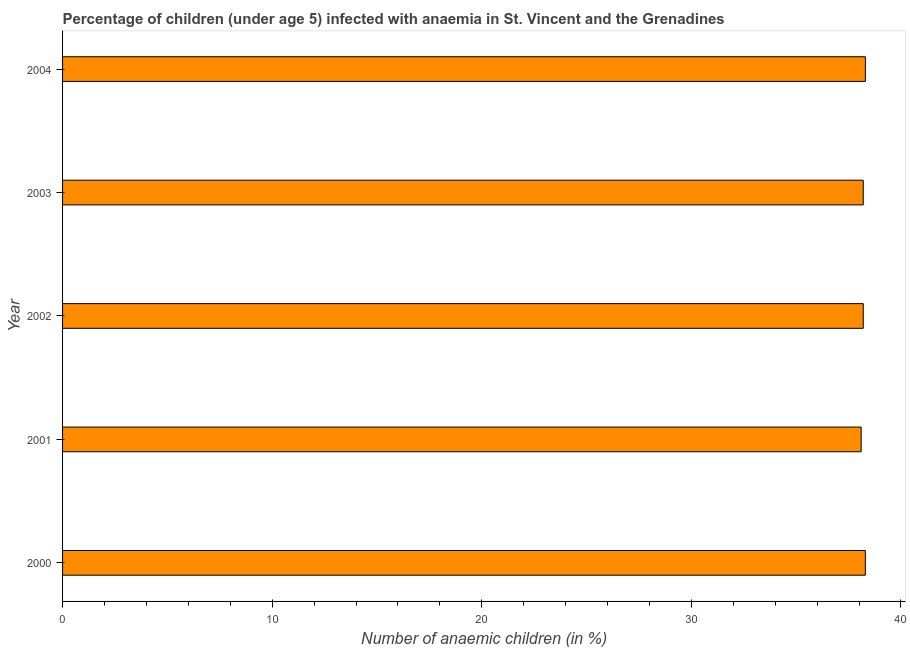Does the graph contain any zero values?
Make the answer very short. No. Does the graph contain grids?
Make the answer very short. No. What is the title of the graph?
Make the answer very short. Percentage of children (under age 5) infected with anaemia in St. Vincent and the Grenadines. What is the label or title of the X-axis?
Make the answer very short. Number of anaemic children (in %). What is the number of anaemic children in 2001?
Provide a succinct answer. 38.1. Across all years, what is the maximum number of anaemic children?
Make the answer very short. 38.3. Across all years, what is the minimum number of anaemic children?
Your answer should be compact. 38.1. In which year was the number of anaemic children maximum?
Offer a very short reply. 2000. In which year was the number of anaemic children minimum?
Offer a very short reply. 2001. What is the sum of the number of anaemic children?
Offer a terse response. 191.1. What is the average number of anaemic children per year?
Keep it short and to the point. 38.22. What is the median number of anaemic children?
Make the answer very short. 38.2. Do a majority of the years between 2003 and 2000 (inclusive) have number of anaemic children greater than 8 %?
Make the answer very short. Yes. What is the ratio of the number of anaemic children in 2001 to that in 2003?
Make the answer very short. 1. Is the number of anaemic children in 2000 less than that in 2004?
Provide a succinct answer. No. What is the difference between the highest and the lowest number of anaemic children?
Offer a terse response. 0.2. How many bars are there?
Offer a very short reply. 5. Are all the bars in the graph horizontal?
Ensure brevity in your answer.  Yes. How many years are there in the graph?
Offer a very short reply. 5. What is the difference between two consecutive major ticks on the X-axis?
Give a very brief answer. 10. Are the values on the major ticks of X-axis written in scientific E-notation?
Your response must be concise. No. What is the Number of anaemic children (in %) of 2000?
Provide a succinct answer. 38.3. What is the Number of anaemic children (in %) of 2001?
Make the answer very short. 38.1. What is the Number of anaemic children (in %) in 2002?
Offer a very short reply. 38.2. What is the Number of anaemic children (in %) in 2003?
Your response must be concise. 38.2. What is the Number of anaemic children (in %) in 2004?
Your answer should be very brief. 38.3. What is the difference between the Number of anaemic children (in %) in 2000 and 2003?
Give a very brief answer. 0.1. What is the difference between the Number of anaemic children (in %) in 2001 and 2003?
Your answer should be very brief. -0.1. What is the difference between the Number of anaemic children (in %) in 2001 and 2004?
Your response must be concise. -0.2. What is the difference between the Number of anaemic children (in %) in 2002 and 2003?
Make the answer very short. 0. What is the ratio of the Number of anaemic children (in %) in 2000 to that in 2002?
Ensure brevity in your answer.  1. What is the ratio of the Number of anaemic children (in %) in 2001 to that in 2002?
Offer a very short reply. 1. What is the ratio of the Number of anaemic children (in %) in 2001 to that in 2003?
Make the answer very short. 1. What is the ratio of the Number of anaemic children (in %) in 2001 to that in 2004?
Provide a succinct answer. 0.99. What is the ratio of the Number of anaemic children (in %) in 2002 to that in 2003?
Make the answer very short. 1. 